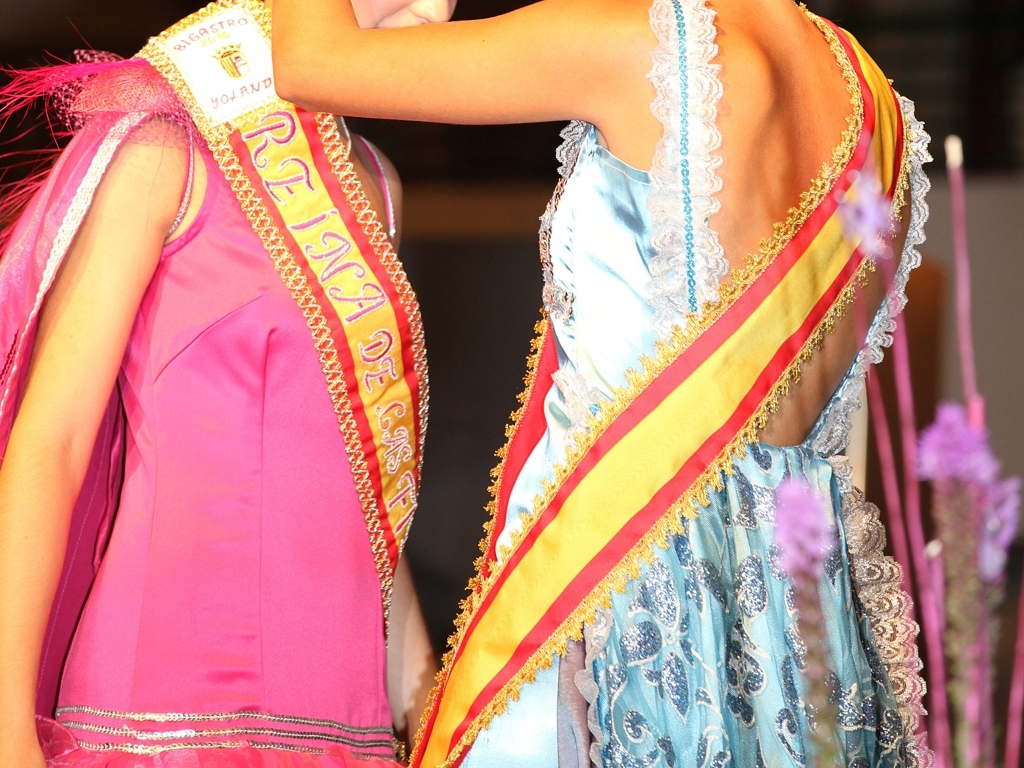What does the choice of colors in their outfits suggest? The vibrant colors like pink and azure, combined with gold accents, suggest that the event is festive and possibly has a cultural significance. Such vivid hues often signify celebration and are likely chosen to be eye-catching and representative of specific themes or organizations. Could the colors represent any specific cultural or regional themes? While the specific cultural or regional themes are not directly identifiable without context, bright colors like these are often associated with celebratory occasions in many cultures. They may be chosen to reflect the vibrancy of a community, its traditions, or seasonal festivities. 